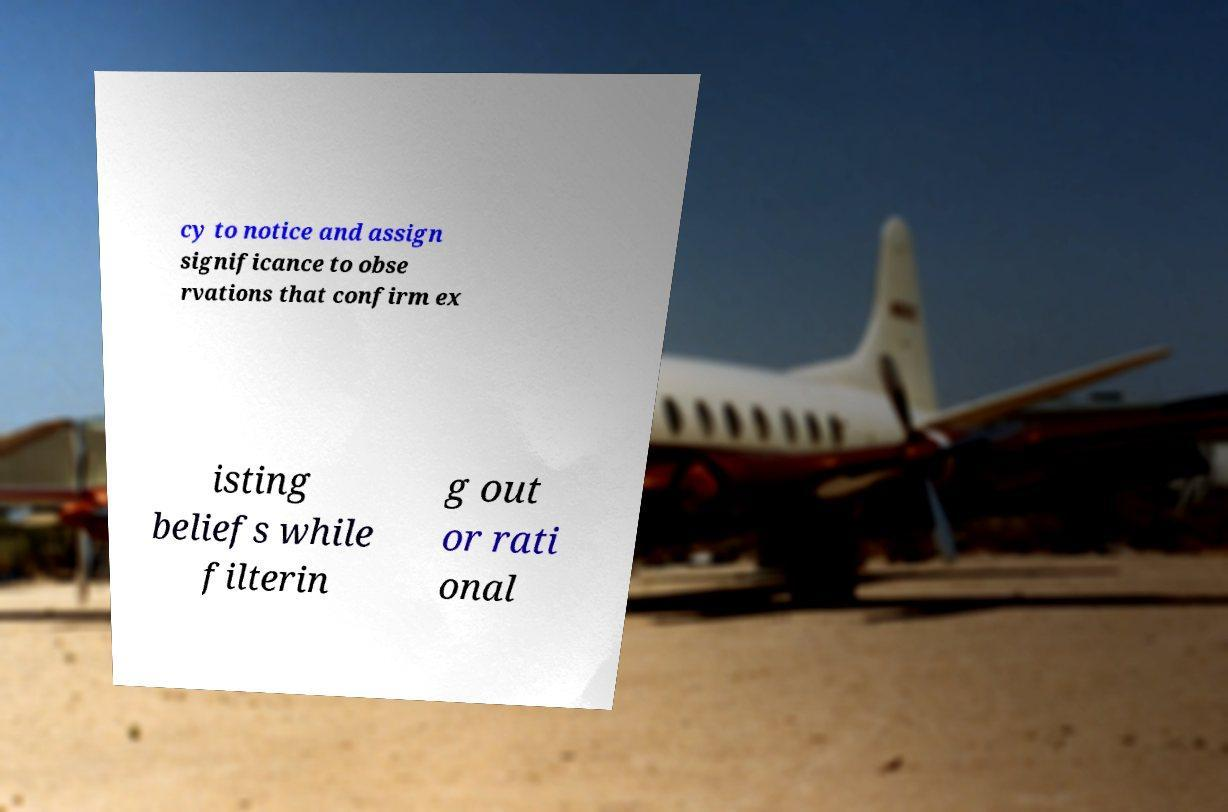Can you accurately transcribe the text from the provided image for me? cy to notice and assign significance to obse rvations that confirm ex isting beliefs while filterin g out or rati onal 